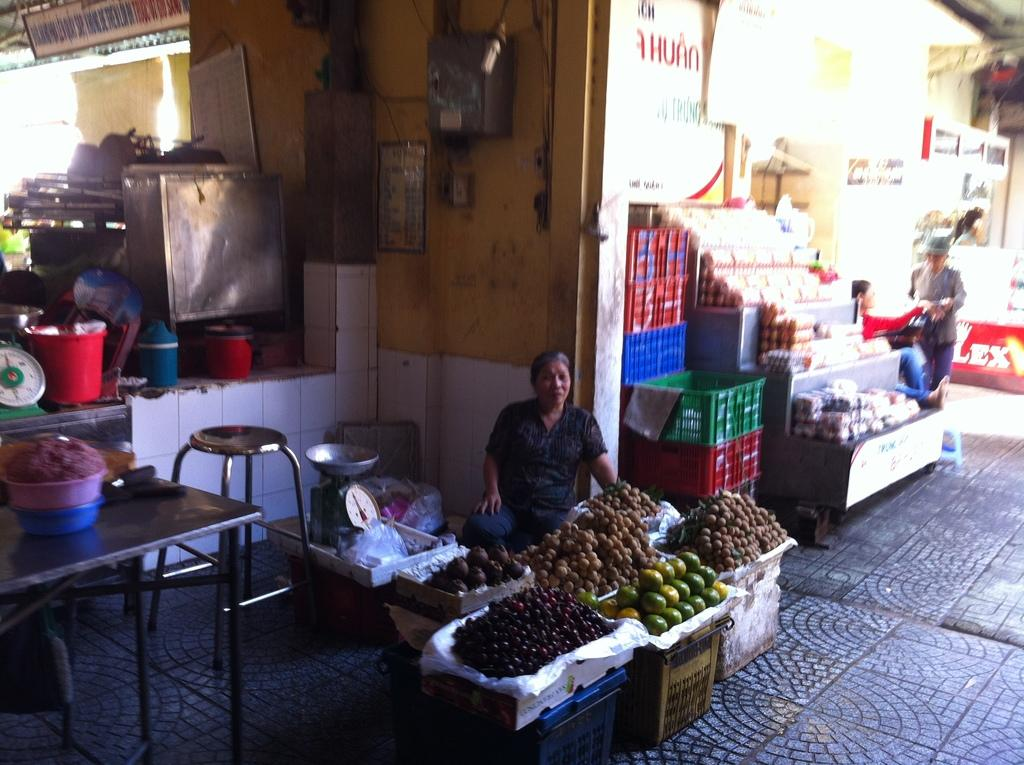What objects are present in the image that are used for holding items? There are baskets, boxes, and a table in the image that are used for holding items. What type of food can be seen in the image? There are fruits in the image. What objects are present in the image that are used for covering items? There are plastic covers in the image that are used for covering items. What objects are present in the image that are used for weighing items? There are weighing machines in the image that are used for weighing items. What object is present in the image that can be used for sitting? There is a stool in the image that can be used for sitting. What objects are present in the image that are used for displaying information? There are name boards, posters, and boards in the image that are used for displaying information. How many people are present in the image? There are people in the image. What type of disease is being treated in the image? There is no indication of any disease or medical treatment in the image. What type of polish is being applied to the objects in the image? There is no polish or polishing activity visible in the image. 